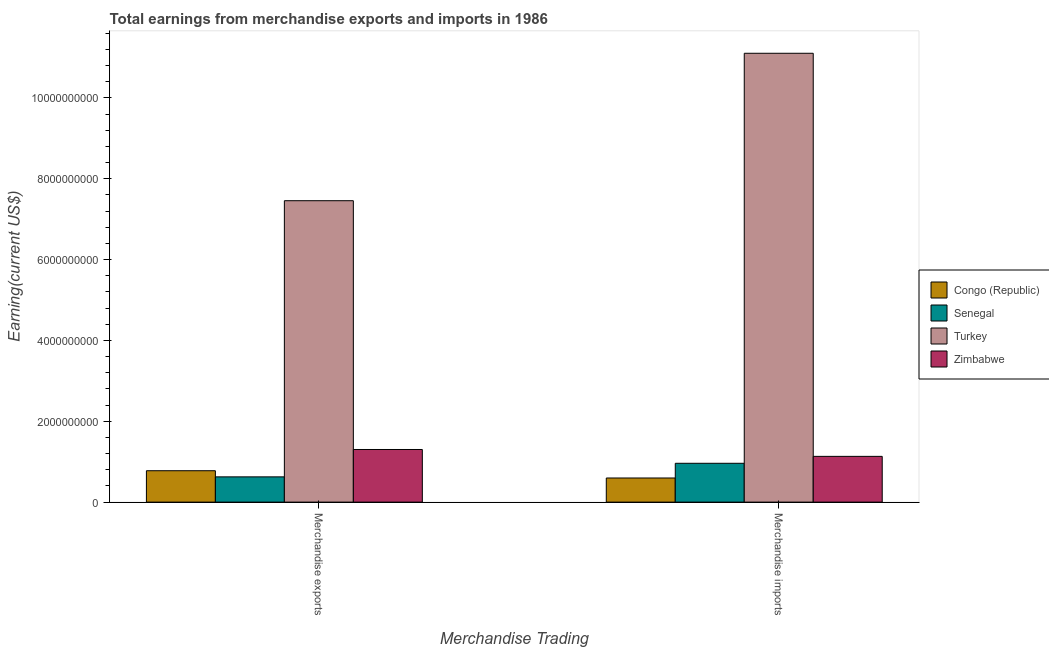How many different coloured bars are there?
Your answer should be compact. 4. Are the number of bars per tick equal to the number of legend labels?
Your answer should be very brief. Yes. How many bars are there on the 1st tick from the left?
Give a very brief answer. 4. How many bars are there on the 1st tick from the right?
Offer a very short reply. 4. What is the earnings from merchandise exports in Senegal?
Your answer should be very brief. 6.25e+08. Across all countries, what is the maximum earnings from merchandise exports?
Your response must be concise. 7.46e+09. Across all countries, what is the minimum earnings from merchandise imports?
Your answer should be compact. 5.97e+08. In which country was the earnings from merchandise imports maximum?
Your answer should be very brief. Turkey. In which country was the earnings from merchandise exports minimum?
Make the answer very short. Senegal. What is the total earnings from merchandise exports in the graph?
Provide a succinct answer. 1.02e+1. What is the difference between the earnings from merchandise exports in Zimbabwe and that in Senegal?
Provide a short and direct response. 6.77e+08. What is the difference between the earnings from merchandise imports in Zimbabwe and the earnings from merchandise exports in Senegal?
Provide a short and direct response. 5.07e+08. What is the average earnings from merchandise imports per country?
Your answer should be compact. 3.45e+09. What is the difference between the earnings from merchandise exports and earnings from merchandise imports in Congo (Republic)?
Provide a short and direct response. 1.80e+08. What is the ratio of the earnings from merchandise imports in Zimbabwe to that in Turkey?
Provide a succinct answer. 0.1. In how many countries, is the earnings from merchandise exports greater than the average earnings from merchandise exports taken over all countries?
Make the answer very short. 1. What does the 1st bar from the left in Merchandise exports represents?
Offer a very short reply. Congo (Republic). What does the 4th bar from the right in Merchandise imports represents?
Offer a terse response. Congo (Republic). Are all the bars in the graph horizontal?
Offer a very short reply. No. How many countries are there in the graph?
Provide a short and direct response. 4. What is the difference between two consecutive major ticks on the Y-axis?
Your response must be concise. 2.00e+09. Are the values on the major ticks of Y-axis written in scientific E-notation?
Keep it short and to the point. No. Does the graph contain any zero values?
Offer a very short reply. No. Does the graph contain grids?
Make the answer very short. No. Where does the legend appear in the graph?
Give a very brief answer. Center right. How are the legend labels stacked?
Your answer should be compact. Vertical. What is the title of the graph?
Provide a succinct answer. Total earnings from merchandise exports and imports in 1986. What is the label or title of the X-axis?
Offer a terse response. Merchandise Trading. What is the label or title of the Y-axis?
Provide a succinct answer. Earning(current US$). What is the Earning(current US$) in Congo (Republic) in Merchandise exports?
Make the answer very short. 7.77e+08. What is the Earning(current US$) of Senegal in Merchandise exports?
Offer a terse response. 6.25e+08. What is the Earning(current US$) of Turkey in Merchandise exports?
Make the answer very short. 7.46e+09. What is the Earning(current US$) in Zimbabwe in Merchandise exports?
Offer a terse response. 1.30e+09. What is the Earning(current US$) in Congo (Republic) in Merchandise imports?
Provide a succinct answer. 5.97e+08. What is the Earning(current US$) in Senegal in Merchandise imports?
Make the answer very short. 9.61e+08. What is the Earning(current US$) in Turkey in Merchandise imports?
Offer a terse response. 1.11e+1. What is the Earning(current US$) of Zimbabwe in Merchandise imports?
Your answer should be compact. 1.13e+09. Across all Merchandise Trading, what is the maximum Earning(current US$) of Congo (Republic)?
Your answer should be very brief. 7.77e+08. Across all Merchandise Trading, what is the maximum Earning(current US$) of Senegal?
Provide a succinct answer. 9.61e+08. Across all Merchandise Trading, what is the maximum Earning(current US$) of Turkey?
Offer a terse response. 1.11e+1. Across all Merchandise Trading, what is the maximum Earning(current US$) of Zimbabwe?
Make the answer very short. 1.30e+09. Across all Merchandise Trading, what is the minimum Earning(current US$) of Congo (Republic)?
Your response must be concise. 5.97e+08. Across all Merchandise Trading, what is the minimum Earning(current US$) in Senegal?
Offer a terse response. 6.25e+08. Across all Merchandise Trading, what is the minimum Earning(current US$) in Turkey?
Keep it short and to the point. 7.46e+09. Across all Merchandise Trading, what is the minimum Earning(current US$) in Zimbabwe?
Keep it short and to the point. 1.13e+09. What is the total Earning(current US$) in Congo (Republic) in the graph?
Offer a very short reply. 1.37e+09. What is the total Earning(current US$) of Senegal in the graph?
Provide a short and direct response. 1.59e+09. What is the total Earning(current US$) in Turkey in the graph?
Give a very brief answer. 1.86e+1. What is the total Earning(current US$) in Zimbabwe in the graph?
Offer a very short reply. 2.43e+09. What is the difference between the Earning(current US$) of Congo (Republic) in Merchandise exports and that in Merchandise imports?
Your answer should be very brief. 1.80e+08. What is the difference between the Earning(current US$) of Senegal in Merchandise exports and that in Merchandise imports?
Offer a terse response. -3.36e+08. What is the difference between the Earning(current US$) of Turkey in Merchandise exports and that in Merchandise imports?
Offer a terse response. -3.65e+09. What is the difference between the Earning(current US$) of Zimbabwe in Merchandise exports and that in Merchandise imports?
Provide a short and direct response. 1.70e+08. What is the difference between the Earning(current US$) of Congo (Republic) in Merchandise exports and the Earning(current US$) of Senegal in Merchandise imports?
Your answer should be compact. -1.84e+08. What is the difference between the Earning(current US$) of Congo (Republic) in Merchandise exports and the Earning(current US$) of Turkey in Merchandise imports?
Provide a succinct answer. -1.03e+1. What is the difference between the Earning(current US$) in Congo (Republic) in Merchandise exports and the Earning(current US$) in Zimbabwe in Merchandise imports?
Keep it short and to the point. -3.55e+08. What is the difference between the Earning(current US$) of Senegal in Merchandise exports and the Earning(current US$) of Turkey in Merchandise imports?
Your answer should be very brief. -1.05e+1. What is the difference between the Earning(current US$) of Senegal in Merchandise exports and the Earning(current US$) of Zimbabwe in Merchandise imports?
Your answer should be very brief. -5.07e+08. What is the difference between the Earning(current US$) in Turkey in Merchandise exports and the Earning(current US$) in Zimbabwe in Merchandise imports?
Offer a terse response. 6.32e+09. What is the average Earning(current US$) in Congo (Republic) per Merchandise Trading?
Give a very brief answer. 6.87e+08. What is the average Earning(current US$) in Senegal per Merchandise Trading?
Give a very brief answer. 7.93e+08. What is the average Earning(current US$) of Turkey per Merchandise Trading?
Provide a short and direct response. 9.28e+09. What is the average Earning(current US$) in Zimbabwe per Merchandise Trading?
Offer a very short reply. 1.22e+09. What is the difference between the Earning(current US$) of Congo (Republic) and Earning(current US$) of Senegal in Merchandise exports?
Offer a terse response. 1.52e+08. What is the difference between the Earning(current US$) in Congo (Republic) and Earning(current US$) in Turkey in Merchandise exports?
Provide a short and direct response. -6.68e+09. What is the difference between the Earning(current US$) of Congo (Republic) and Earning(current US$) of Zimbabwe in Merchandise exports?
Your response must be concise. -5.25e+08. What is the difference between the Earning(current US$) of Senegal and Earning(current US$) of Turkey in Merchandise exports?
Keep it short and to the point. -6.83e+09. What is the difference between the Earning(current US$) in Senegal and Earning(current US$) in Zimbabwe in Merchandise exports?
Your answer should be very brief. -6.77e+08. What is the difference between the Earning(current US$) in Turkey and Earning(current US$) in Zimbabwe in Merchandise exports?
Offer a terse response. 6.16e+09. What is the difference between the Earning(current US$) in Congo (Republic) and Earning(current US$) in Senegal in Merchandise imports?
Provide a short and direct response. -3.64e+08. What is the difference between the Earning(current US$) of Congo (Republic) and Earning(current US$) of Turkey in Merchandise imports?
Offer a very short reply. -1.05e+1. What is the difference between the Earning(current US$) of Congo (Republic) and Earning(current US$) of Zimbabwe in Merchandise imports?
Your answer should be very brief. -5.35e+08. What is the difference between the Earning(current US$) in Senegal and Earning(current US$) in Turkey in Merchandise imports?
Offer a terse response. -1.01e+1. What is the difference between the Earning(current US$) in Senegal and Earning(current US$) in Zimbabwe in Merchandise imports?
Offer a very short reply. -1.71e+08. What is the difference between the Earning(current US$) in Turkey and Earning(current US$) in Zimbabwe in Merchandise imports?
Make the answer very short. 9.97e+09. What is the ratio of the Earning(current US$) in Congo (Republic) in Merchandise exports to that in Merchandise imports?
Your answer should be compact. 1.3. What is the ratio of the Earning(current US$) of Senegal in Merchandise exports to that in Merchandise imports?
Make the answer very short. 0.65. What is the ratio of the Earning(current US$) in Turkey in Merchandise exports to that in Merchandise imports?
Provide a succinct answer. 0.67. What is the ratio of the Earning(current US$) of Zimbabwe in Merchandise exports to that in Merchandise imports?
Give a very brief answer. 1.15. What is the difference between the highest and the second highest Earning(current US$) of Congo (Republic)?
Provide a short and direct response. 1.80e+08. What is the difference between the highest and the second highest Earning(current US$) in Senegal?
Keep it short and to the point. 3.36e+08. What is the difference between the highest and the second highest Earning(current US$) of Turkey?
Provide a short and direct response. 3.65e+09. What is the difference between the highest and the second highest Earning(current US$) in Zimbabwe?
Keep it short and to the point. 1.70e+08. What is the difference between the highest and the lowest Earning(current US$) of Congo (Republic)?
Provide a short and direct response. 1.80e+08. What is the difference between the highest and the lowest Earning(current US$) in Senegal?
Keep it short and to the point. 3.36e+08. What is the difference between the highest and the lowest Earning(current US$) in Turkey?
Provide a succinct answer. 3.65e+09. What is the difference between the highest and the lowest Earning(current US$) in Zimbabwe?
Your answer should be very brief. 1.70e+08. 